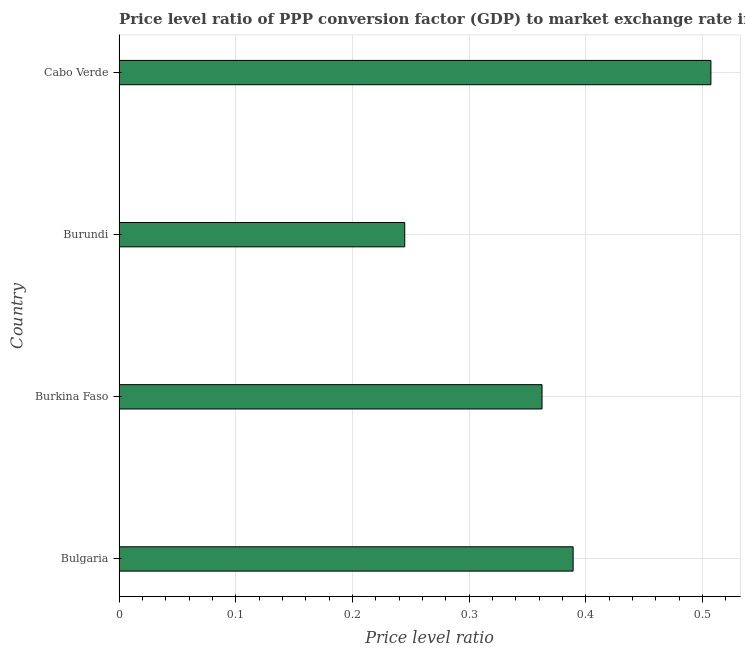Does the graph contain any zero values?
Give a very brief answer. No. What is the title of the graph?
Your answer should be very brief. Price level ratio of PPP conversion factor (GDP) to market exchange rate in 2006. What is the label or title of the X-axis?
Make the answer very short. Price level ratio. What is the price level ratio in Cabo Verde?
Your response must be concise. 0.51. Across all countries, what is the maximum price level ratio?
Ensure brevity in your answer.  0.51. Across all countries, what is the minimum price level ratio?
Keep it short and to the point. 0.24. In which country was the price level ratio maximum?
Provide a succinct answer. Cabo Verde. In which country was the price level ratio minimum?
Your answer should be compact. Burundi. What is the sum of the price level ratio?
Provide a succinct answer. 1.5. What is the difference between the price level ratio in Bulgaria and Burkina Faso?
Make the answer very short. 0.03. What is the average price level ratio per country?
Offer a very short reply. 0.38. What is the median price level ratio?
Offer a very short reply. 0.38. What is the ratio of the price level ratio in Bulgaria to that in Burundi?
Give a very brief answer. 1.59. What is the difference between the highest and the second highest price level ratio?
Your answer should be compact. 0.12. Is the sum of the price level ratio in Burkina Faso and Burundi greater than the maximum price level ratio across all countries?
Your answer should be compact. Yes. What is the difference between the highest and the lowest price level ratio?
Make the answer very short. 0.26. How many bars are there?
Make the answer very short. 4. Are all the bars in the graph horizontal?
Provide a succinct answer. Yes. How many countries are there in the graph?
Offer a terse response. 4. What is the Price level ratio of Bulgaria?
Give a very brief answer. 0.39. What is the Price level ratio in Burkina Faso?
Ensure brevity in your answer.  0.36. What is the Price level ratio of Burundi?
Your answer should be very brief. 0.24. What is the Price level ratio of Cabo Verde?
Your answer should be compact. 0.51. What is the difference between the Price level ratio in Bulgaria and Burkina Faso?
Provide a succinct answer. 0.03. What is the difference between the Price level ratio in Bulgaria and Burundi?
Offer a terse response. 0.14. What is the difference between the Price level ratio in Bulgaria and Cabo Verde?
Make the answer very short. -0.12. What is the difference between the Price level ratio in Burkina Faso and Burundi?
Ensure brevity in your answer.  0.12. What is the difference between the Price level ratio in Burkina Faso and Cabo Verde?
Offer a terse response. -0.14. What is the difference between the Price level ratio in Burundi and Cabo Verde?
Provide a succinct answer. -0.26. What is the ratio of the Price level ratio in Bulgaria to that in Burkina Faso?
Your answer should be compact. 1.07. What is the ratio of the Price level ratio in Bulgaria to that in Burundi?
Make the answer very short. 1.59. What is the ratio of the Price level ratio in Bulgaria to that in Cabo Verde?
Your response must be concise. 0.77. What is the ratio of the Price level ratio in Burkina Faso to that in Burundi?
Offer a terse response. 1.48. What is the ratio of the Price level ratio in Burkina Faso to that in Cabo Verde?
Your answer should be compact. 0.71. What is the ratio of the Price level ratio in Burundi to that in Cabo Verde?
Give a very brief answer. 0.48. 